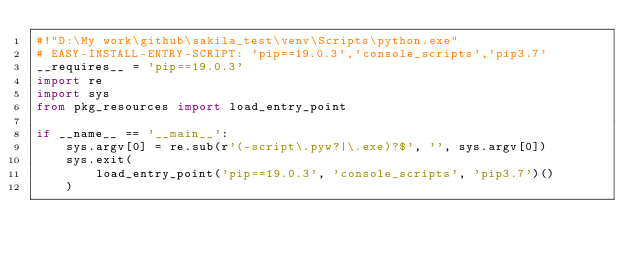<code> <loc_0><loc_0><loc_500><loc_500><_Python_>#!"D:\My work\github\sakila_test\venv\Scripts\python.exe"
# EASY-INSTALL-ENTRY-SCRIPT: 'pip==19.0.3','console_scripts','pip3.7'
__requires__ = 'pip==19.0.3'
import re
import sys
from pkg_resources import load_entry_point

if __name__ == '__main__':
    sys.argv[0] = re.sub(r'(-script\.pyw?|\.exe)?$', '', sys.argv[0])
    sys.exit(
        load_entry_point('pip==19.0.3', 'console_scripts', 'pip3.7')()
    )
</code> 